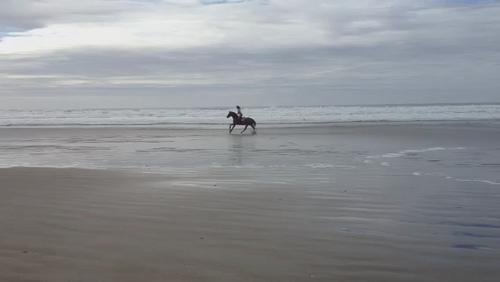Question: where is the horse?
Choices:
A. On the beach.
B. On the farm.
C. On the road.
D. On the racetrack.
Answer with the letter. Answer: A Question: who is riding?
Choices:
A. Man.
B. Child.
C. Woman.
D. Jockey.
Answer with the letter. Answer: C Question: what is she riding?
Choices:
A. Lion.
B. Bull.
C. Horse.
D. Goat.
Answer with the letter. Answer: C Question: why are the waves choppy?
Choices:
A. Bad weather.
B. Storm.
C. Earthquake.
D. Wind.
Answer with the letter. Answer: D 